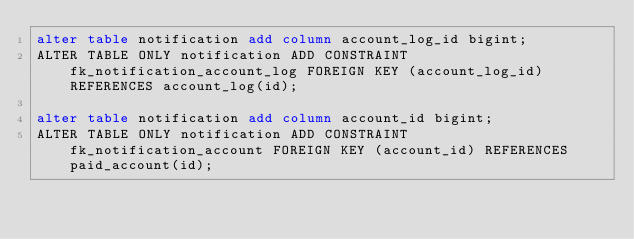Convert code to text. <code><loc_0><loc_0><loc_500><loc_500><_SQL_>alter table notification add column account_log_id bigint;
ALTER TABLE ONLY notification ADD CONSTRAINT fk_notification_account_log FOREIGN KEY (account_log_id) REFERENCES account_log(id);

alter table notification add column account_id bigint;
ALTER TABLE ONLY notification ADD CONSTRAINT fk_notification_account FOREIGN KEY (account_id) REFERENCES paid_account(id);
</code> 